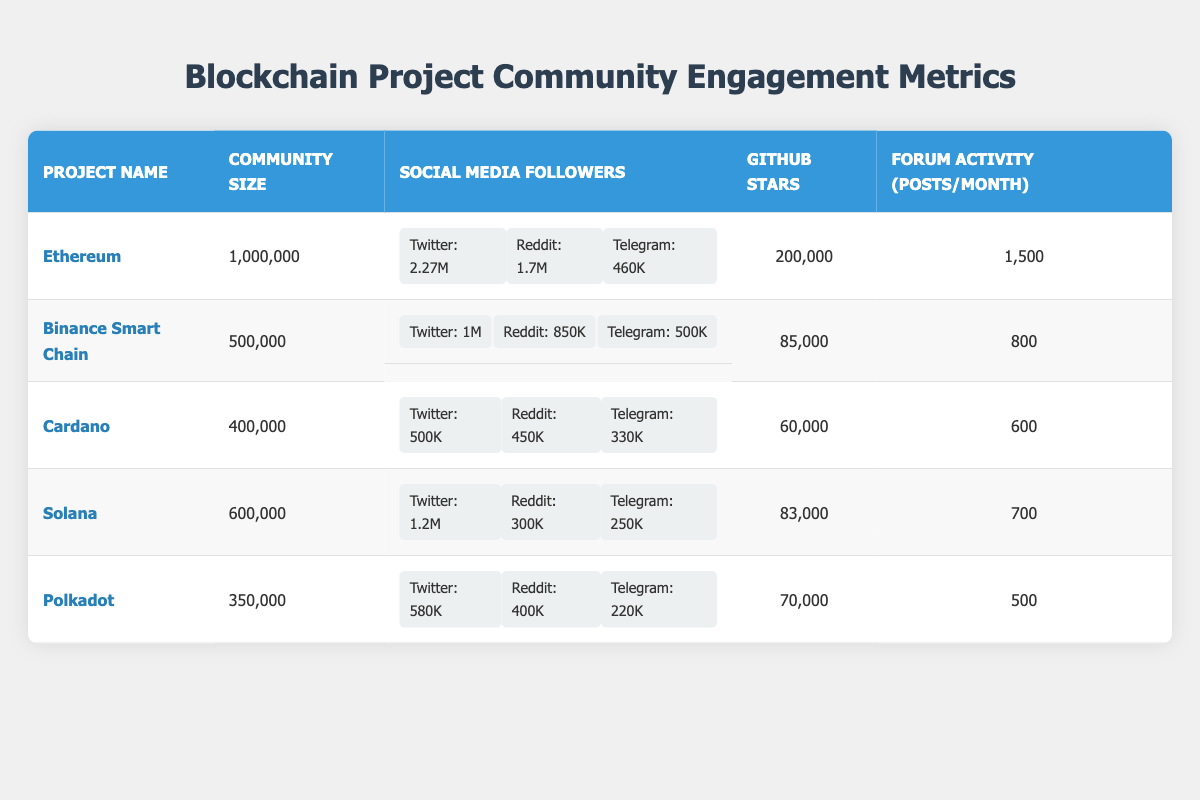What is the community size of Ethereum? The table shows that the community size for Ethereum is directly listed under the relevant column. By referring to that row, the value can be found easily.
Answer: 1,000,000 Which blockchain project has the most GitHub stars? In the GitHub Stars column, by comparing the values for each project, Ethereum has the highest number of stars at 200,000.
Answer: Ethereum How many more social media followers does Binance Smart Chain have on Twitter compared to Solana? The Twitter followers for Binance Smart Chain are 1,000,000 and for Solana are 1,200,000. By calculating the difference: 1,200,000 - 1,000,000 = 200,000.
Answer: 200,000 Is Polkadot's forum activity higher than Cardano's? The forum activity for Polkadot is 500 posts per month and for Cardano is 600 posts per month. Since 500 is less than 600, the answer is no.
Answer: No What is the total number of social media followers (Twitter, Reddit, and Telegram) for Ethereum? To find this, we sum the followers from each platform: Twitter (2,270,000) + Reddit (1,700,000) + Telegram (460,000) = 4,430,000.
Answer: 4,430,000 Which project has the highest number of social media followers across all platforms? We calculate the total followers for each project and find that Ethereum has the highest total: 4,430,000, followed by Binance Smart Chain with 2,350,000, making Ethereum the project with the highest overall social media presence.
Answer: Ethereum What is the average GitHub stars of the listed blockchain projects? The total number of GitHub stars is 200,000 + 85,000 + 60,000 + 83,000 + 70,000 = 498,000. There are 5 projects, so the average is 498,000 / 5 = 99,600.
Answer: 99,600 Does Solana have a larger community size than Polkadot? By comparing the community sizes, Solana has 600,000 and Polkadot has 350,000. Since 600,000 is greater than 350,000, the answer is yes.
Answer: Yes How many posts per month does Cardano have compared to Ethereum? Cardano has 600 forum activity posts per month and Ethereum has 1,500. Since 600 is less than 1,500, the difference indicates Cardano has fewer posts per month.
Answer: Fewer posts 